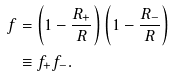<formula> <loc_0><loc_0><loc_500><loc_500>f & = \left ( 1 - \frac { R _ { + } } { R } \right ) \left ( 1 - \frac { R _ { - } } { R } \right ) \\ & \equiv f _ { + } f _ { - } .</formula> 